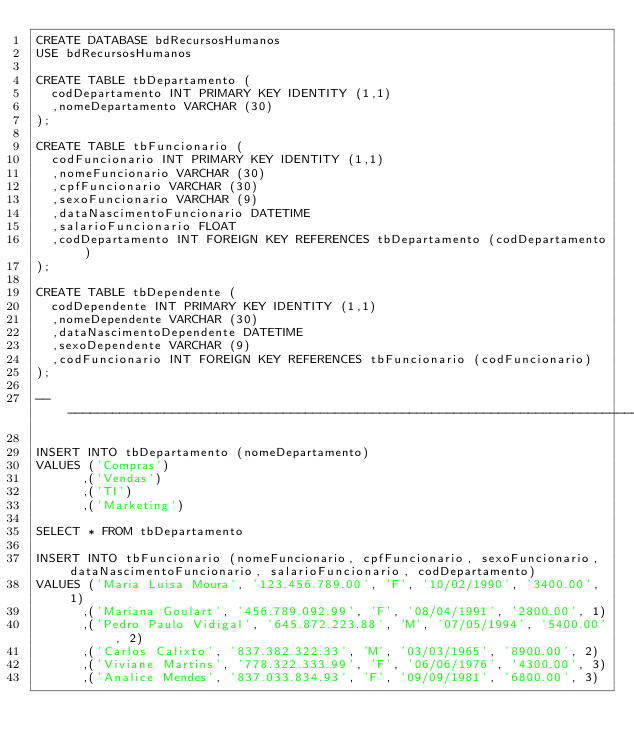Convert code to text. <code><loc_0><loc_0><loc_500><loc_500><_SQL_>CREATE DATABASE bdRecursosHumanos
USE bdRecursosHumanos

CREATE TABLE tbDepartamento (
	codDepartamento INT PRIMARY KEY IDENTITY (1,1)
	,nomeDepartamento VARCHAR (30)
);

CREATE TABLE tbFuncionario (
	codFuncionario INT PRIMARY KEY IDENTITY (1,1)
	,nomeFuncionario VARCHAR (30)
	,cpfFuncionario VARCHAR (30)
	,sexoFuncionario VARCHAR (9)
	,dataNascimentoFuncionario DATETIME
	,salarioFuncionario FLOAT
	,codDepartamento INT FOREIGN KEY REFERENCES tbDepartamento (codDepartamento)
);

CREATE TABLE tbDependente (
	codDependente INT PRIMARY KEY IDENTITY (1,1)
	,nomeDependente VARCHAR (30)
	,dataNascimentoDependente DATETIME
	,sexoDependente VARCHAR (9)
	,codFuncionario INT FOREIGN KEY REFERENCES tbFuncionario (codFuncionario)
);

---------------------------------------------------------------------------------------------------------------------------------------------

INSERT INTO tbDepartamento (nomeDepartamento)
VALUES ('Compras')
      ,('Vendas')
      ,('TI')
      ,('Marketing')

SELECT * FROM tbDepartamento

INSERT INTO tbFuncionario (nomeFuncionario, cpfFuncionario, sexoFuncionario, dataNascimentoFuncionario, salarioFuncionario, codDepartamento)
VALUES ('Maria Luisa Moura', '123.456.789.00', 'F', '10/02/1990', '3400.00', 1)
      ,('Mariana Goulart', '456.789.092.99', 'F', '08/04/1991', '2800.00', 1)
      ,('Pedro Paulo Vidigal', '645.872.223.88', 'M', '07/05/1994', '5400.00', 2)
      ,('Carlos Calixto', '837.382.322.33', 'M', '03/03/1965', '8900.00', 2)
      ,('Viviane Martins', '778.322.333.99', 'F', '06/06/1976', '4300.00', 3)
      ,('Analice Mendes', '837.033.834.93', 'F', '09/09/1981', '6800.00', 3)</code> 